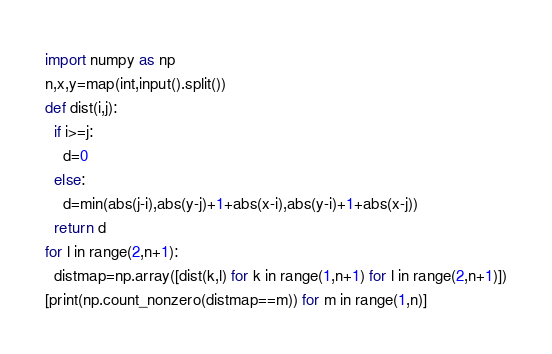Convert code to text. <code><loc_0><loc_0><loc_500><loc_500><_Python_>import numpy as np
n,x,y=map(int,input().split())
def dist(i,j):
  if i>=j:
    d=0
  else:
    d=min(abs(j-i),abs(y-j)+1+abs(x-i),abs(y-i)+1+abs(x-j))
  return d
for l in range(2,n+1):
  distmap=np.array([dist(k,l) for k in range(1,n+1) for l in range(2,n+1)])
[print(np.count_nonzero(distmap==m)) for m in range(1,n)]</code> 